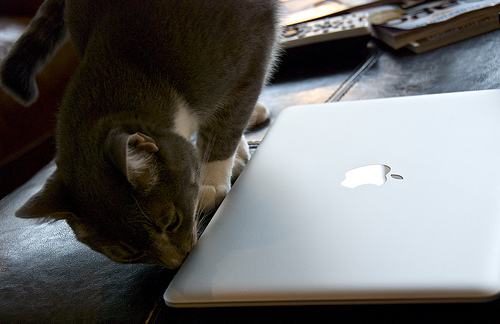What other objects can you see in the picture? Besides the silver laptop and the cat, there appear to be some books or paper items partially visible in the background on the left, but it's not clear exactly what they are from this angle. 